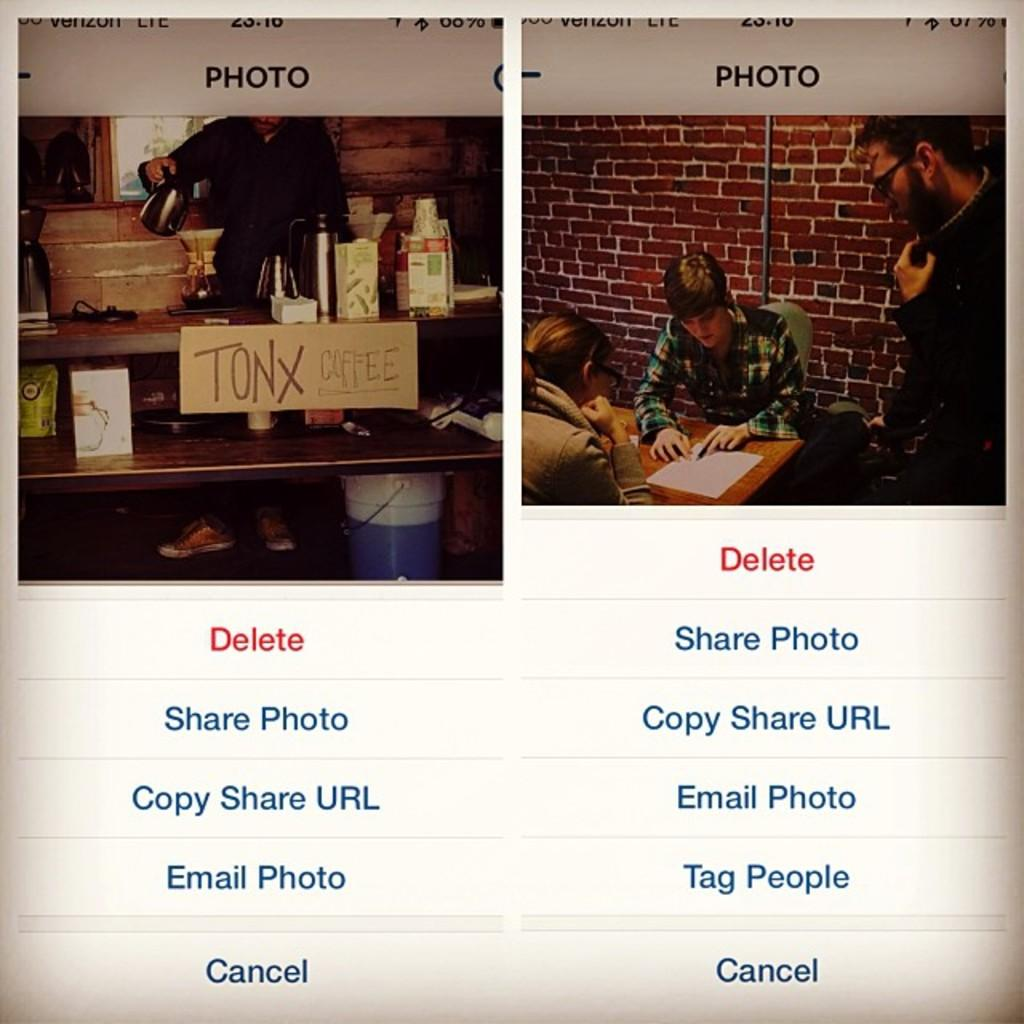Provide a one-sentence caption for the provided image. Close up of a cell phone screen showing some young people studying at a table and a shot of a sign that reads Tonx Coffee. 